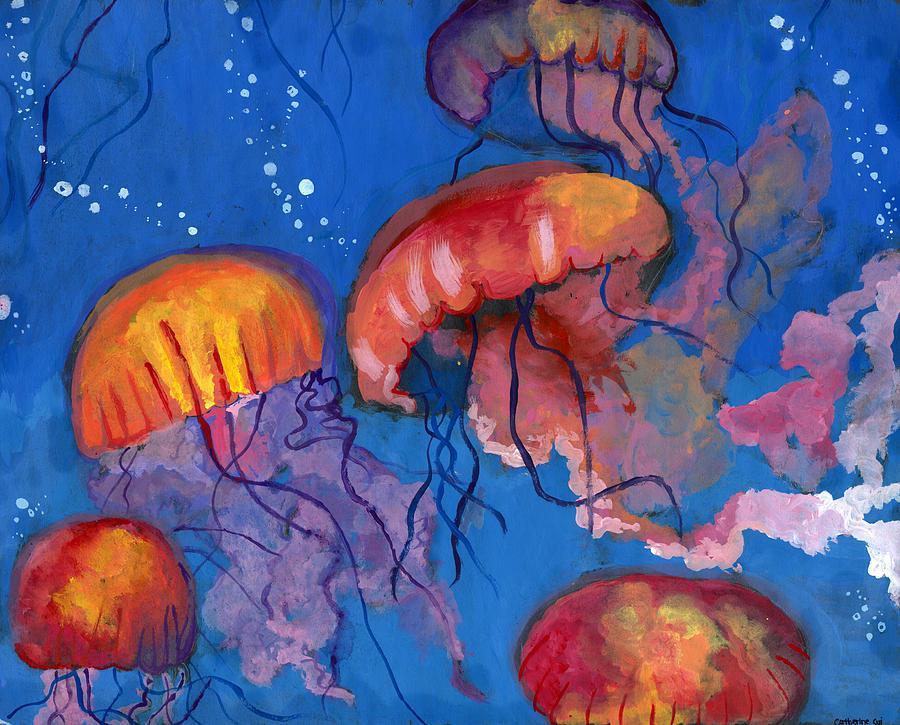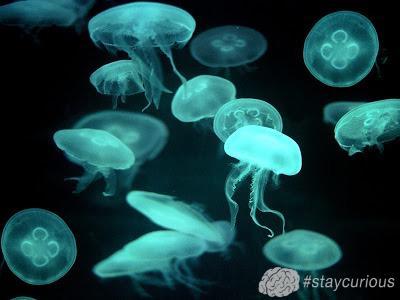The first image is the image on the left, the second image is the image on the right. Examine the images to the left and right. Is the description "There are at least 7 jellyfish swimming down." accurate? Answer yes or no. No. The first image is the image on the left, the second image is the image on the right. Considering the images on both sides, is "all of the jellyfish are swimming with the body facing downward" valid? Answer yes or no. No. 